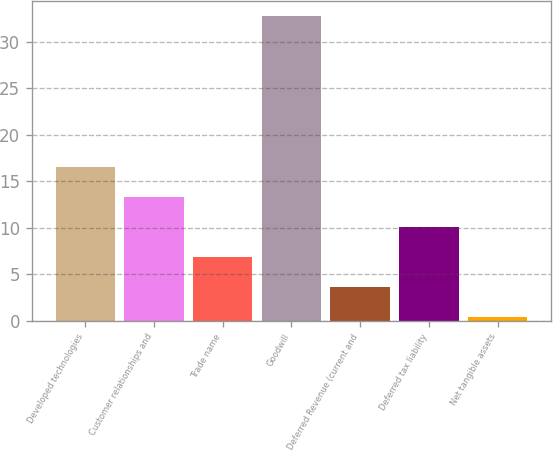<chart> <loc_0><loc_0><loc_500><loc_500><bar_chart><fcel>Developed technologies<fcel>Customer relationships and<fcel>Trade name<fcel>Goodwill<fcel>Deferred Revenue (current and<fcel>Deferred tax liability<fcel>Net tangible assets<nl><fcel>16.6<fcel>13.36<fcel>6.88<fcel>32.8<fcel>3.64<fcel>10.12<fcel>0.4<nl></chart> 